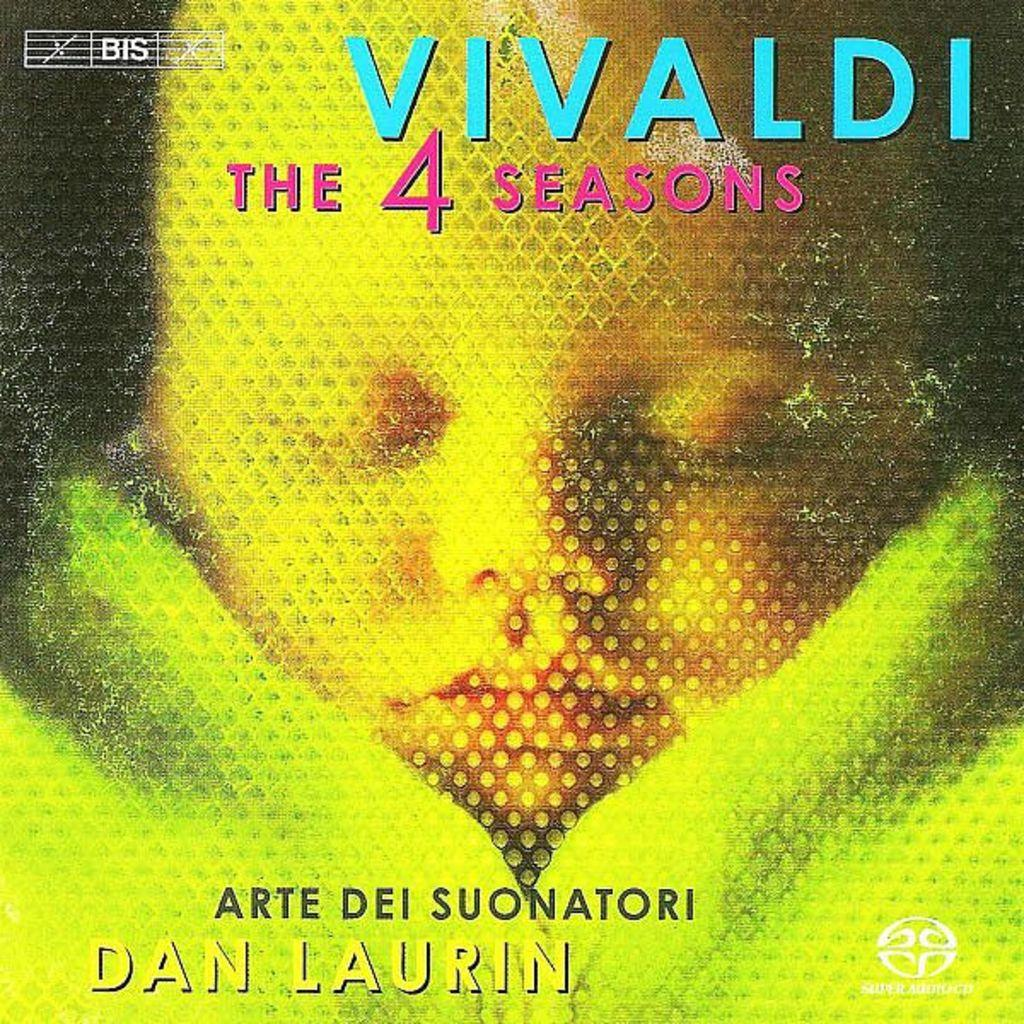<image>
Provide a brief description of the given image. An album cover of Vivaldi's the four seasons 